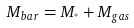<formula> <loc_0><loc_0><loc_500><loc_500>M _ { b a r } = M _ { ^ { * } } + M _ { g a s }</formula> 